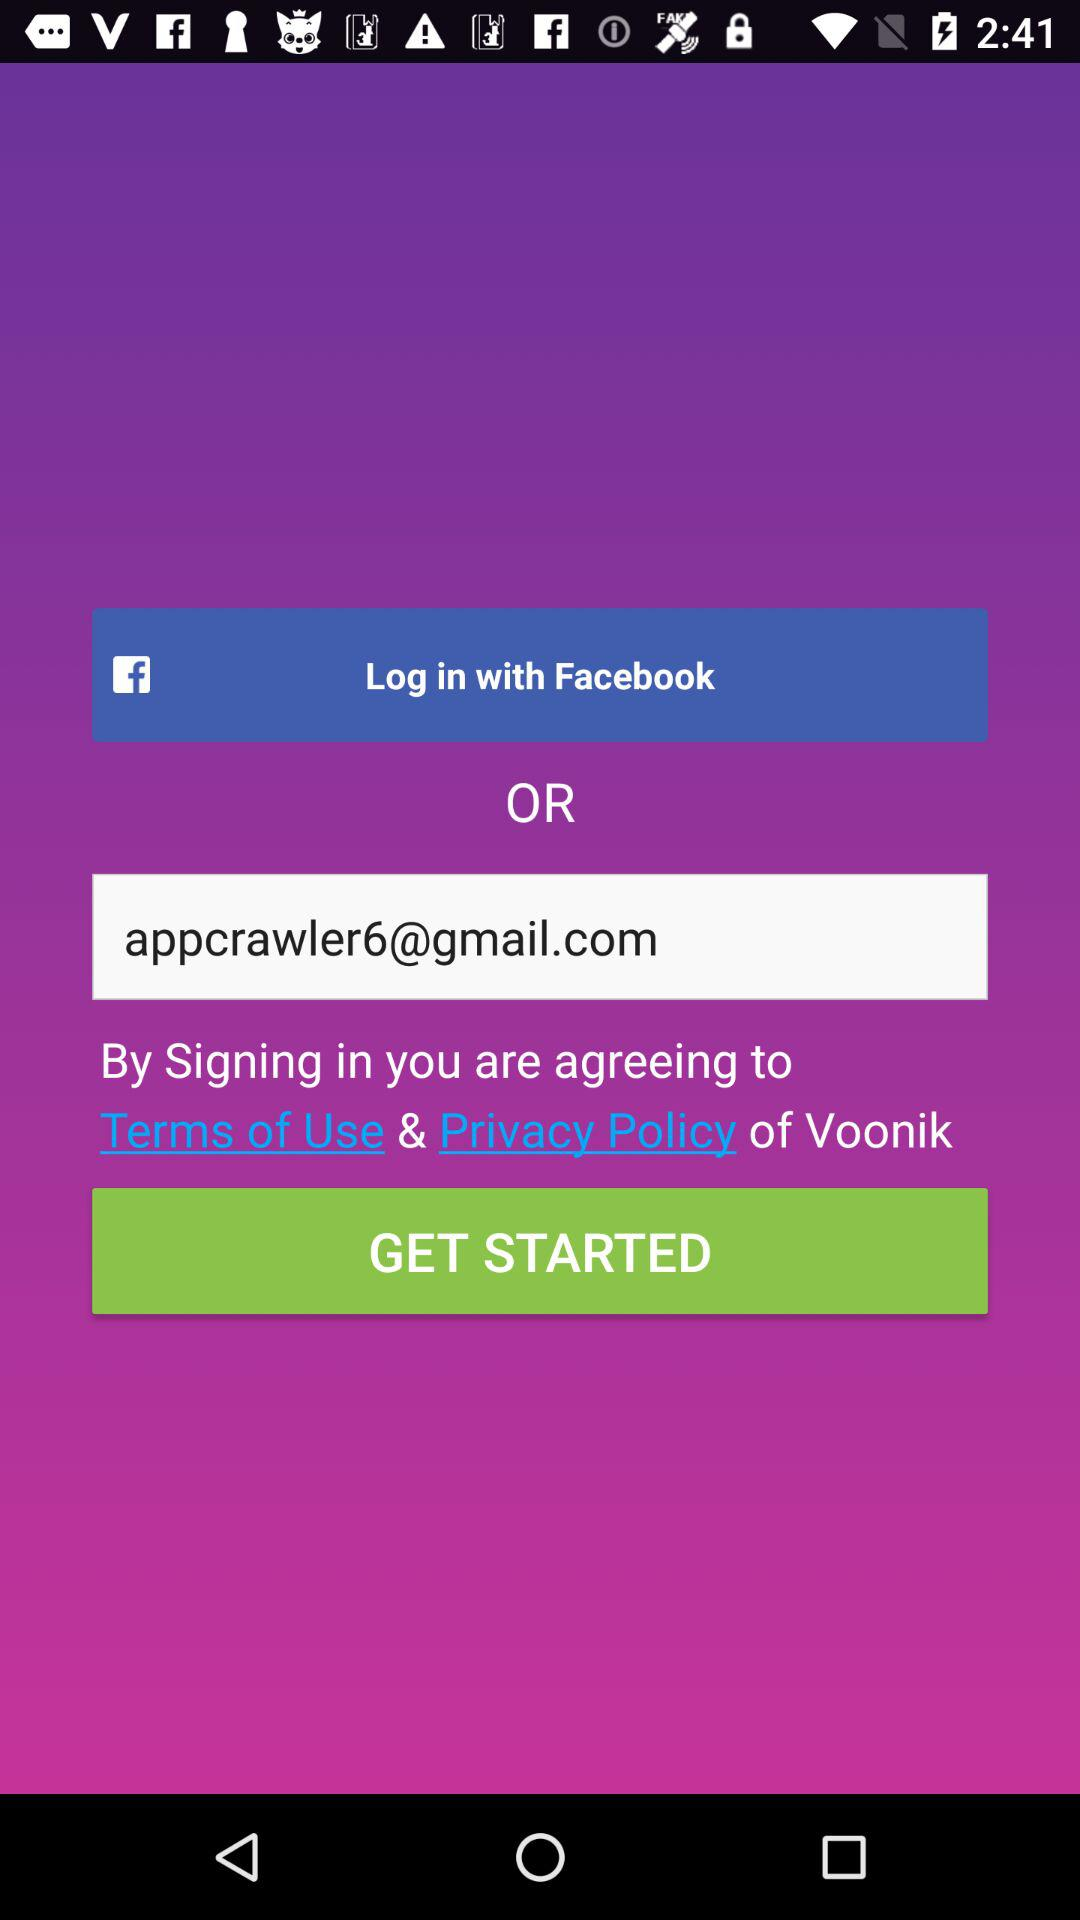What is the email address? The email address is appcrawler6@gmail.com. 